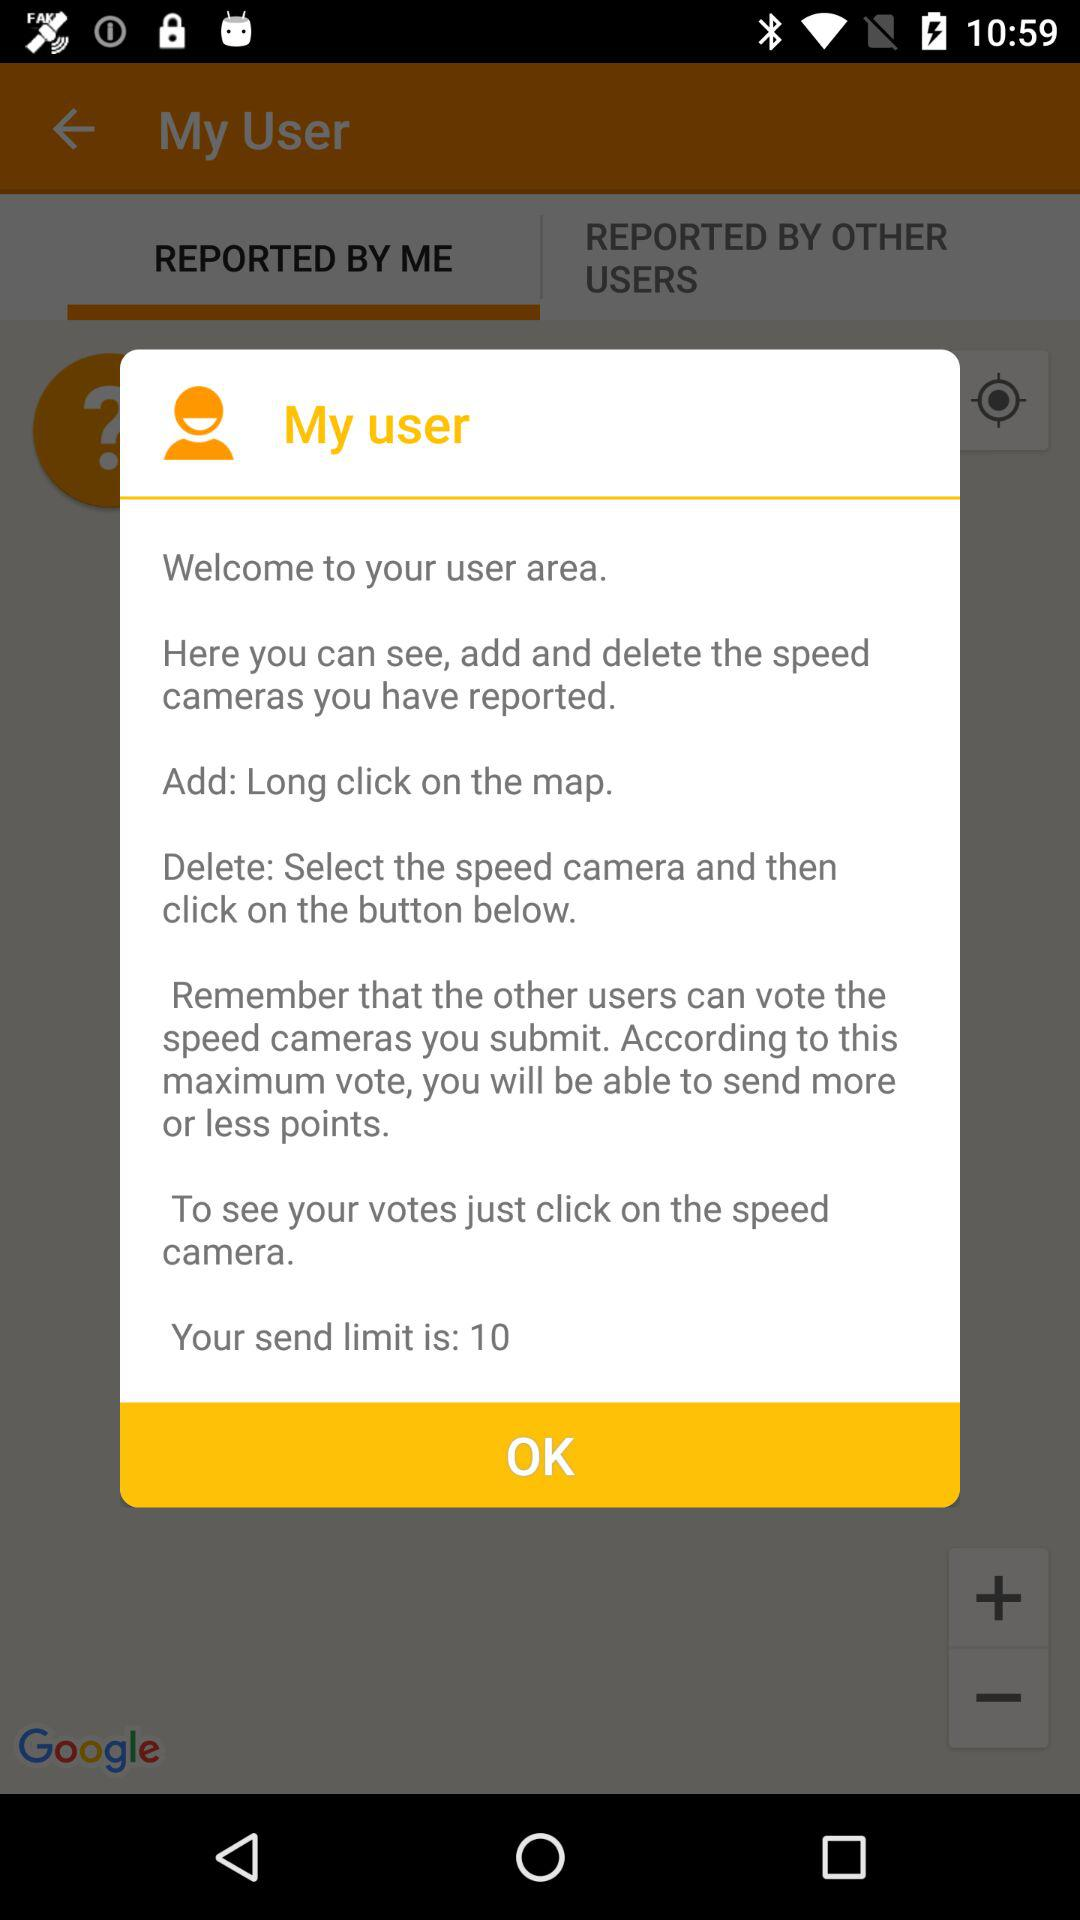What is the name of the user?
When the provided information is insufficient, respond with <no answer>. <no answer> 